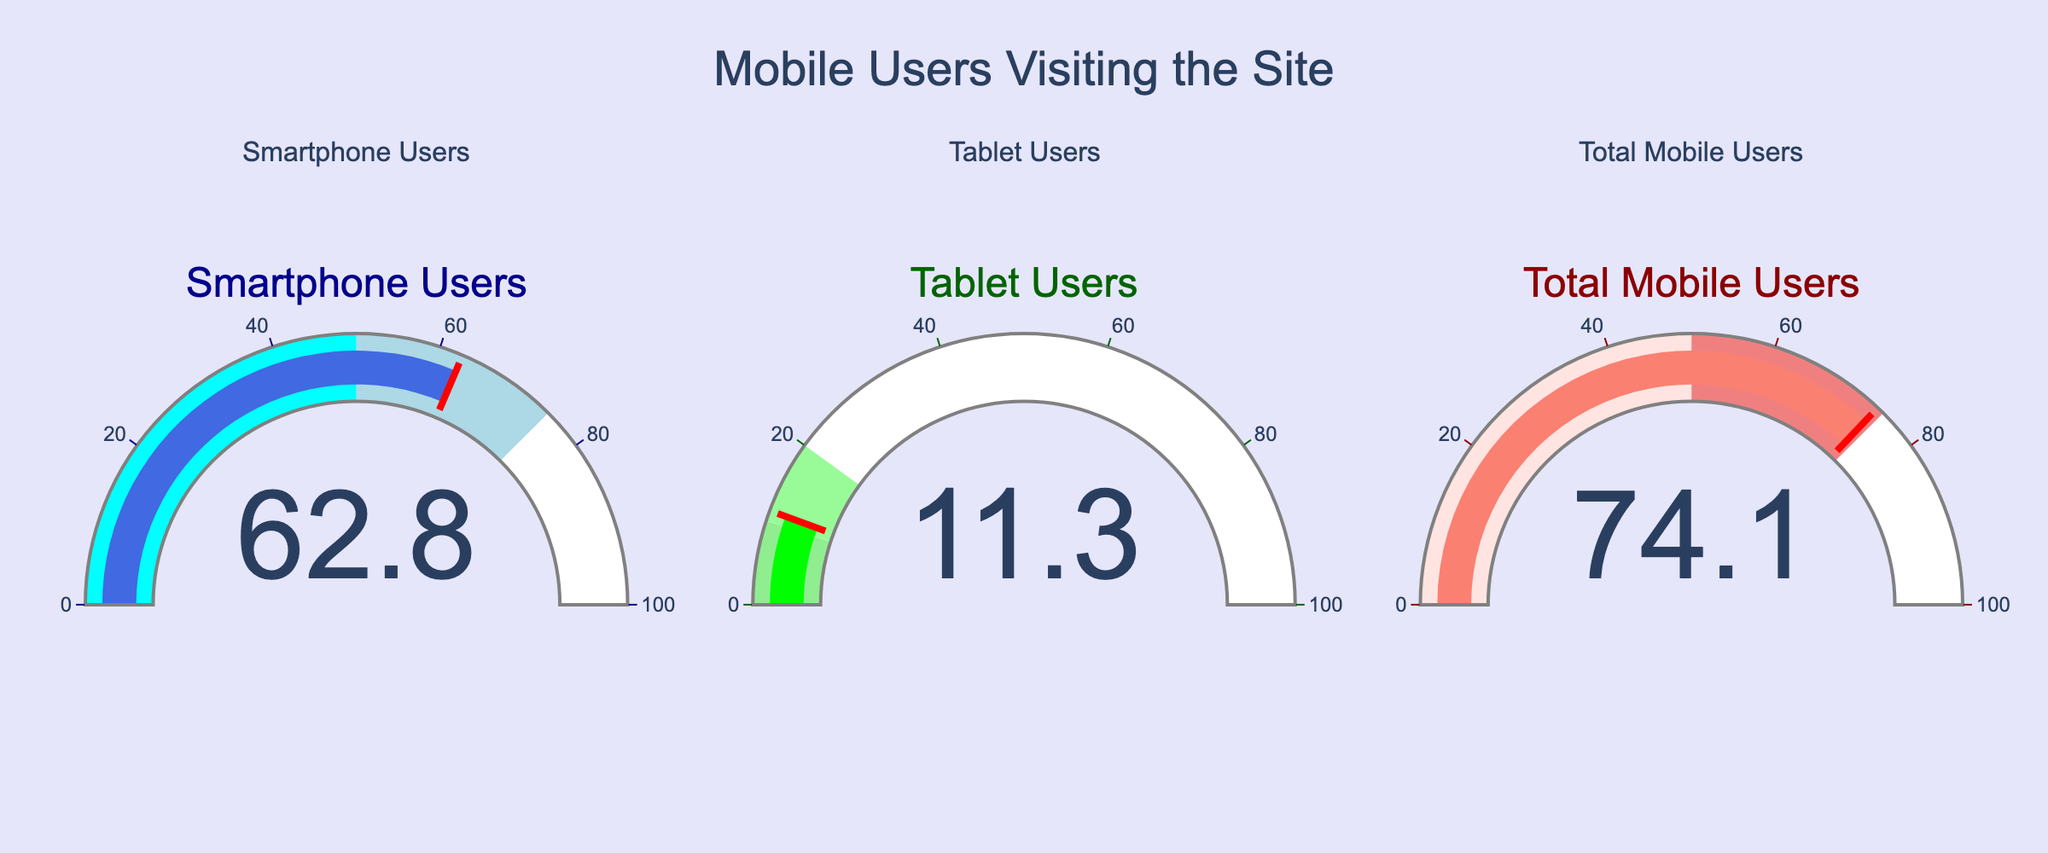What is the title of the figure? The title of the figure is displayed at the top, in larger text compared to other textual elements on the dashboard. It reads "Mobile Users Visiting the Site".
Answer: Mobile Users Visiting the Site What is the percentage of smartphone users visiting the site? The gauge chart for smartphone users shows a value of 62.8%, which is displayed prominently in the middle of the gauge.
Answer: 62.8% Which type of mobile users has the lowest percentage of visits? By looking at the three gauge charts, the tablet users chart has the lowest number at 11.3%.
Answer: Tablet Users How much higher is the percentage of smartphone users compared to tablet users? To find this, subtract the tablet users' percentage from the smartphone users' percentage: 62.8% - 11.3% = 51.5%.
Answer: 51.5% What color is used to represent the bar for 'Total Mobile Users'? The color used to represent the bar for 'Total Mobile Users' is salmon, which is given in the gauge chart for 'Total Mobile Users'.
Answer: Salmon What is the sum of the percentages of smartphone and tablet users? Adding the percentages of smartphone users (62.8%) and tablet users (11.3%) gives us 62.8 + 11.3 = 74.1%.
Answer: 74.1% Which mobile user group has the highest percentage of visits, and what is that percentage? By looking at the three gauges, the 'Total Mobile Users' chart has the highest value, which is 74.1%.
Answer: Total Mobile Users, 74.1% Are all the gauge charts using a background color, and if so, what is it? All three gauge charts use a background color, which is white. This is visible in the background area of all the gauges.
Answer: Yes, white How does the percentage of 'Total Mobile Users' compare with the sum of 'Smartphone Users' and 'Tablet Users'? The percentage of 'Total Mobile Users' exactly equals the sum of 'Smartphone Users' (62.8%) and 'Tablet Users' (11.3%), which is 74.1%.
Answer: They are equal 